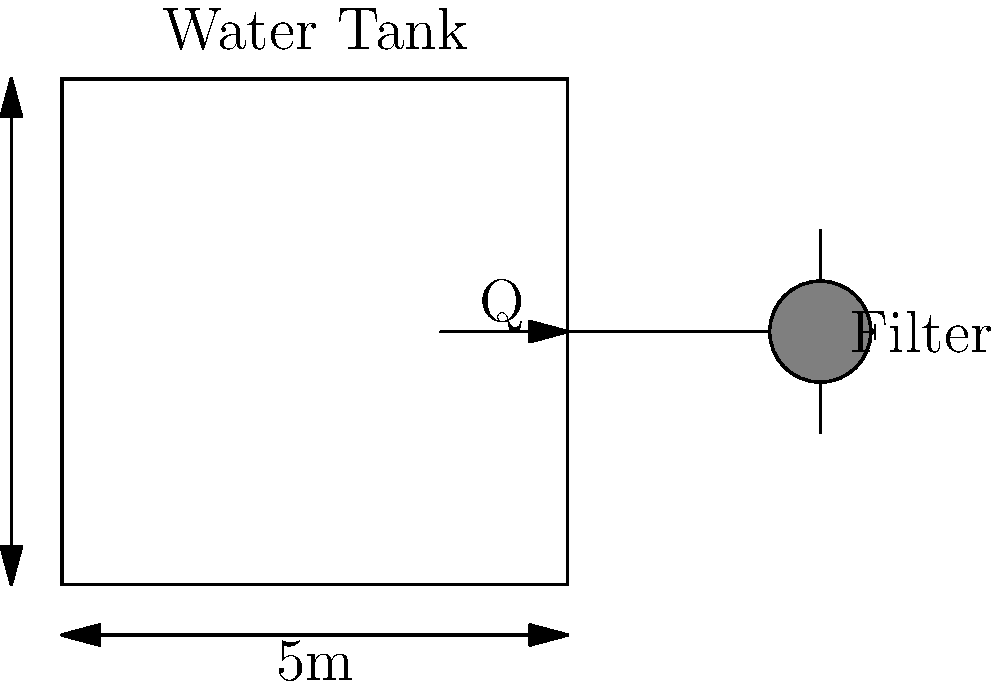A cattle farm requires a water filtration system for its 5m x 3m water tank. If the daily water consumption for the cattle is 15,000 liters and the filter can process 20 liters per minute, what is the minimum number of hours per day the filtration system needs to operate to ensure all the water is filtered? Assume the system uses a single-pass filtration method. To solve this problem, we need to follow these steps:

1. Convert the daily water consumption from liters to cubic meters:
   $15,000 \text{ L} = 15 \text{ m}^3$

2. Calculate the filter's hourly capacity:
   $20 \text{ L/min} \times 60 \text{ min/hour} = 1,200 \text{ L/hour} = 1.2 \text{ m}^3\text{/hour}$

3. Calculate the time needed to filter the daily water consumption:
   $\text{Time} = \frac{\text{Daily water consumption}}{\text{Filter capacity per hour}}$
   $\text{Time} = \frac{15 \text{ m}^3}{1.2 \text{ m}^3\text{/hour}} = 12.5 \text{ hours}$

Therefore, the filtration system needs to operate for a minimum of 12.5 hours per day to ensure all the water is filtered.
Answer: 12.5 hours 